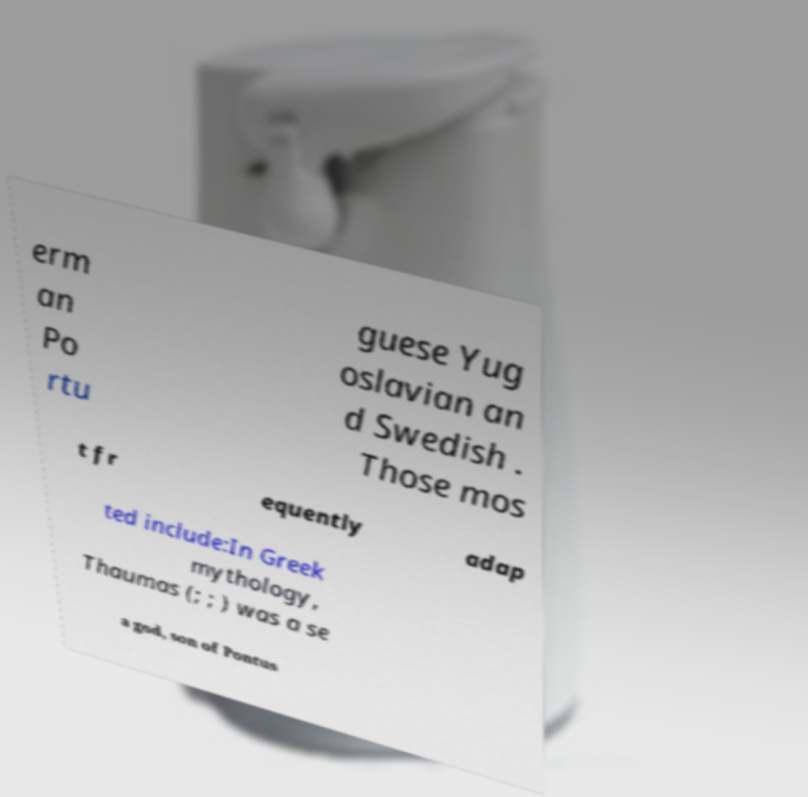There's text embedded in this image that I need extracted. Can you transcribe it verbatim? erm an Po rtu guese Yug oslavian an d Swedish . Those mos t fr equently adap ted include:In Greek mythology, Thaumas (; ; ) was a se a god, son of Pontus 